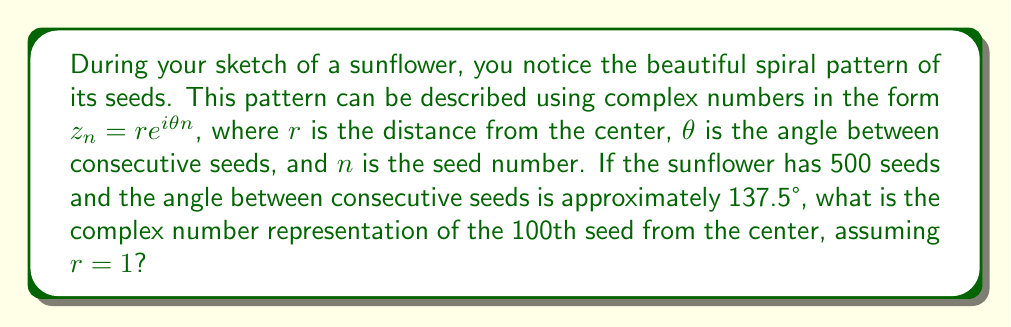Show me your answer to this math problem. Let's approach this step-by-step:

1) We're given the general form of the complex number: $z_n = re^{i\theta n}$

2) We know:
   - $r = 1$ (given in the question)
   - $n = 100$ (we're asked about the 100th seed)
   - $\theta = 137.5°$

3) We need to convert the angle to radians:
   $\theta = 137.5° \times \frac{\pi}{180°} \approx 2.4$ radians

4) Now we can substitute these values into our equation:

   $z_{100} = 1 \cdot e^{i(2.4)(100)}$

5) Simplify:
   $z_{100} = e^{i240}$

6) We can express this in the form $a + bi$ using Euler's formula:
   $e^{ix} = \cos(x) + i\sin(x)$

   So, $z_{100} = \cos(240) + i\sin(240)$

7) Calculate:
   $\cos(240) \approx -0.5$
   $\sin(240) \approx -0.866$

8) Therefore, our final answer is:
   $z_{100} \approx -0.5 - 0.866i$
Answer: $z_{100} \approx -0.5 - 0.866i$ 